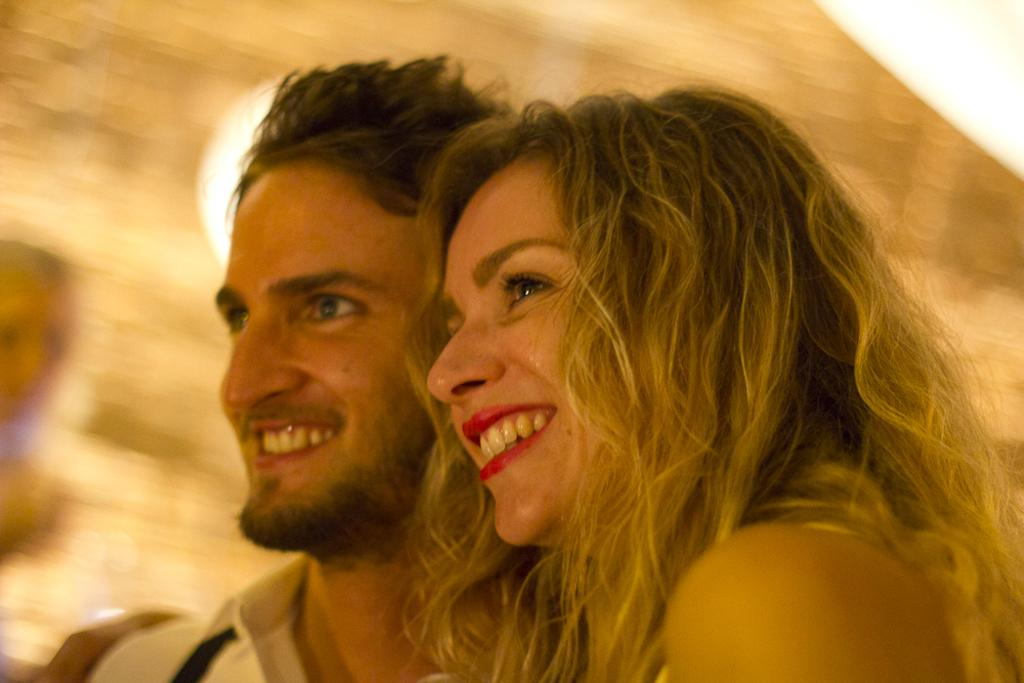Who is present in the image? There is a couple in the image. What are the couple doing in the image? The couple is standing in the front and smiling. How is the background of the image depicted? The background of the image is blurred. What type of truck can be seen in the background of the image? There is no truck present in the image; the background is blurred. How many socks are visible on the couple's feet in the image? There is no information about the couple's feet or socks in the image. 